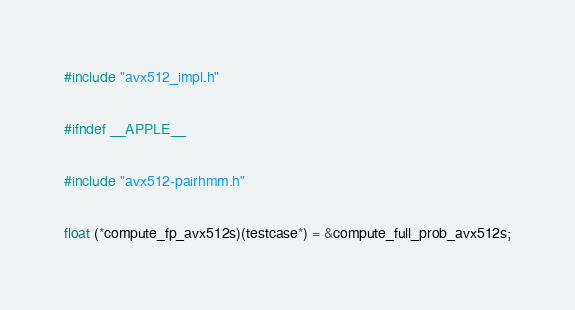Convert code to text. <code><loc_0><loc_0><loc_500><loc_500><_C++_>#include "avx512_impl.h"

#ifndef __APPLE__

#include "avx512-pairhmm.h"

float (*compute_fp_avx512s)(testcase*) = &compute_full_prob_avx512s;</code> 